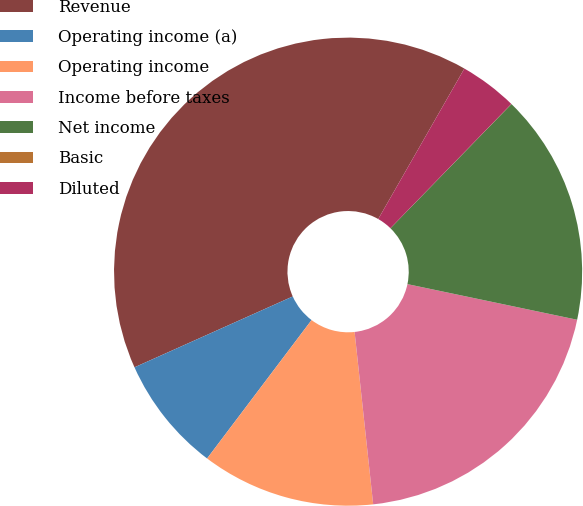Convert chart. <chart><loc_0><loc_0><loc_500><loc_500><pie_chart><fcel>Revenue<fcel>Operating income (a)<fcel>Operating income<fcel>Income before taxes<fcel>Net income<fcel>Basic<fcel>Diluted<nl><fcel>39.98%<fcel>8.01%<fcel>12.0%<fcel>20.0%<fcel>16.0%<fcel>0.01%<fcel>4.01%<nl></chart> 